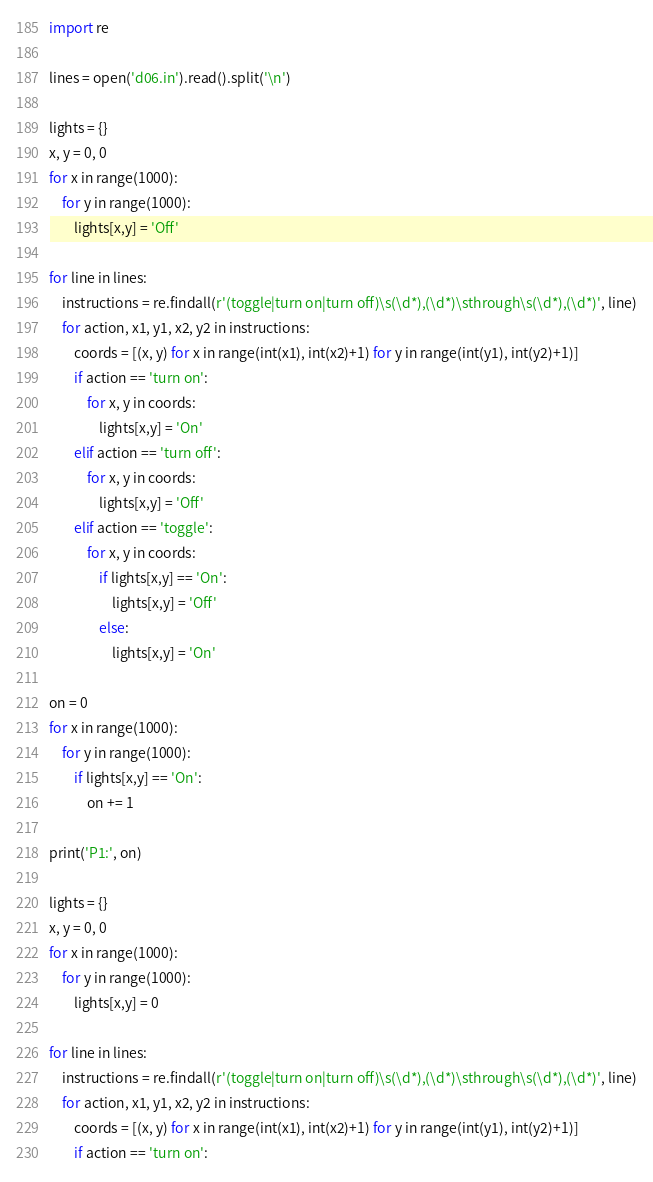<code> <loc_0><loc_0><loc_500><loc_500><_Python_>import re

lines = open('d06.in').read().split('\n')

lights = {}
x, y = 0, 0
for x in range(1000):
    for y in range(1000):
        lights[x,y] = 'Off'

for line in lines:
    instructions = re.findall(r'(toggle|turn on|turn off)\s(\d*),(\d*)\sthrough\s(\d*),(\d*)', line)
    for action, x1, y1, x2, y2 in instructions:
        coords = [(x, y) for x in range(int(x1), int(x2)+1) for y in range(int(y1), int(y2)+1)]
        if action == 'turn on':
            for x, y in coords:
                lights[x,y] = 'On'
        elif action == 'turn off':
            for x, y in coords:
                lights[x,y] = 'Off'
        elif action == 'toggle':
            for x, y in coords:
                if lights[x,y] == 'On':
                    lights[x,y] = 'Off'
                else:
                    lights[x,y] = 'On'

on = 0
for x in range(1000):
    for y in range(1000):
        if lights[x,y] == 'On':
            on += 1

print('P1:', on)
           
lights = {}
x, y = 0, 0
for x in range(1000):
    for y in range(1000):
        lights[x,y] = 0

for line in lines:
    instructions = re.findall(r'(toggle|turn on|turn off)\s(\d*),(\d*)\sthrough\s(\d*),(\d*)', line)
    for action, x1, y1, x2, y2 in instructions:
        coords = [(x, y) for x in range(int(x1), int(x2)+1) for y in range(int(y1), int(y2)+1)]
        if action == 'turn on':</code> 